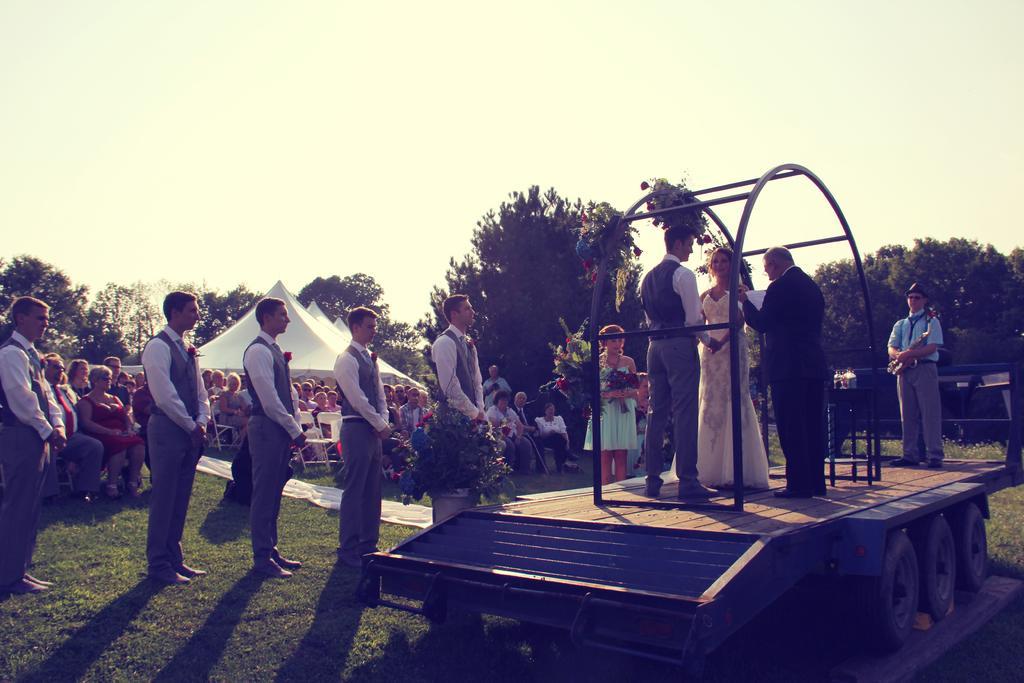Please provide a concise description of this image. On the right side of the image we can see some persons are standing on a truck. In the background of the image we can see a group of people are sitting on the chairs and some of them are standing and also we can see the tents, trees, rods, house. At the bottom of the image we can see the ground. At the top of the image we can see the sky. 